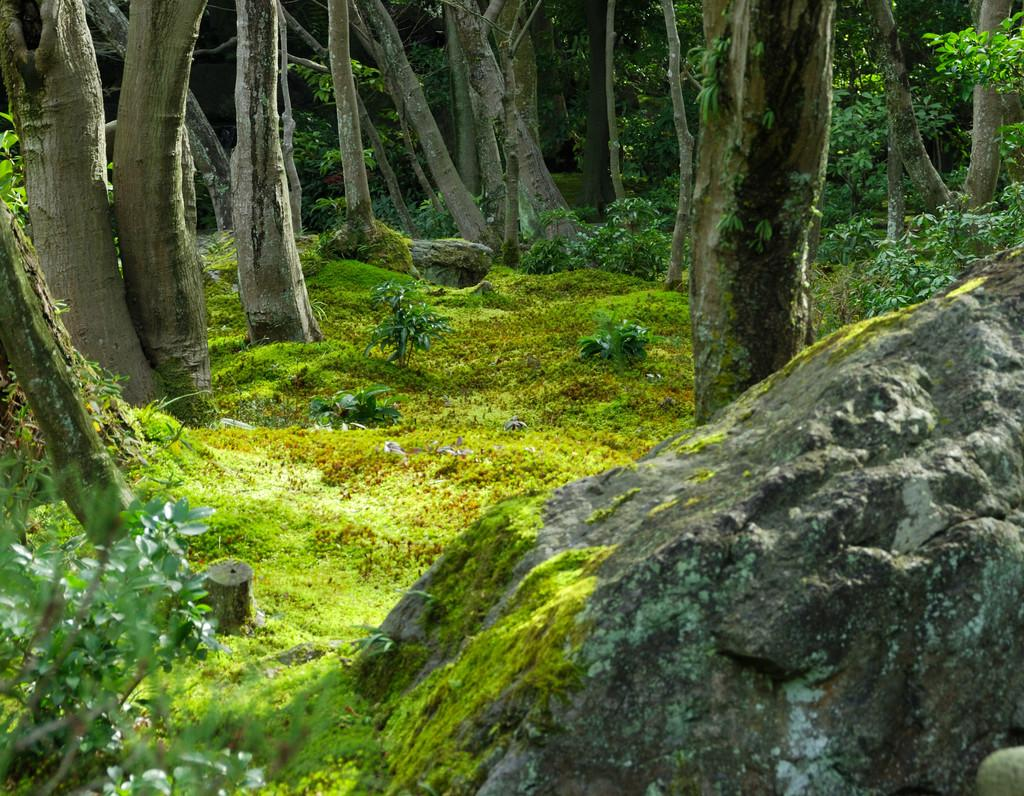What type of natural elements can be seen in the image? There are stones and trees in the image. Can you describe the stones in the image? The stones are visible in the image, but no specific details about their size, shape, or color are provided. What type of vegetation is present in the image? Trees are present in the image. What color is the vest worn by the crying person in the image? There is no person wearing a vest or crying in the image; it only features stones and trees. 